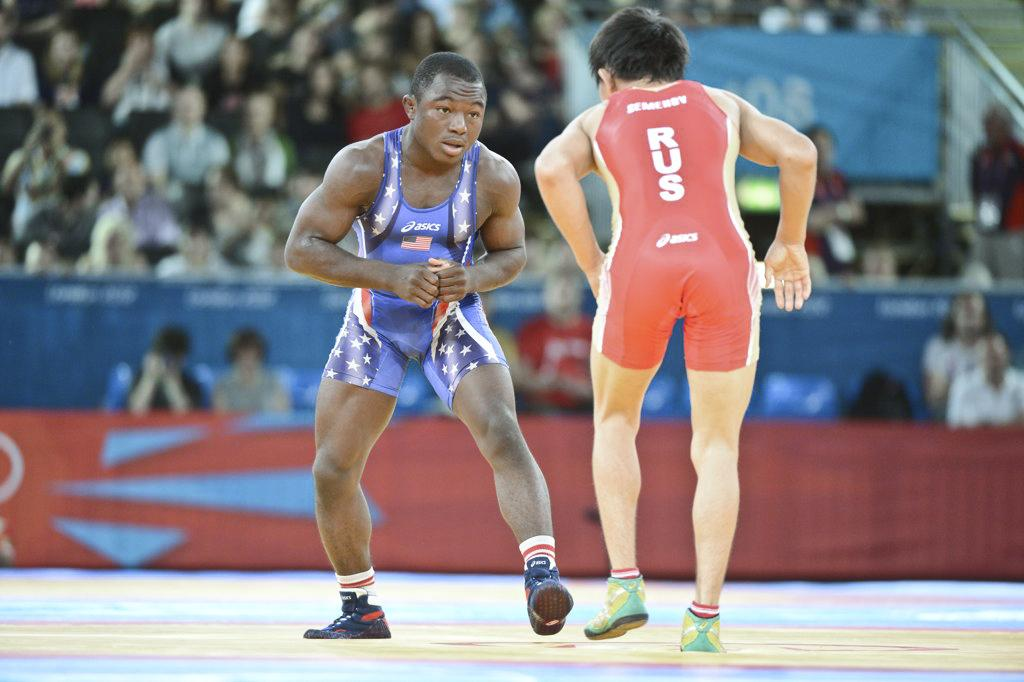<image>
Share a concise interpretation of the image provided. A man in an RUS singlet wrestles with a man in blue. 